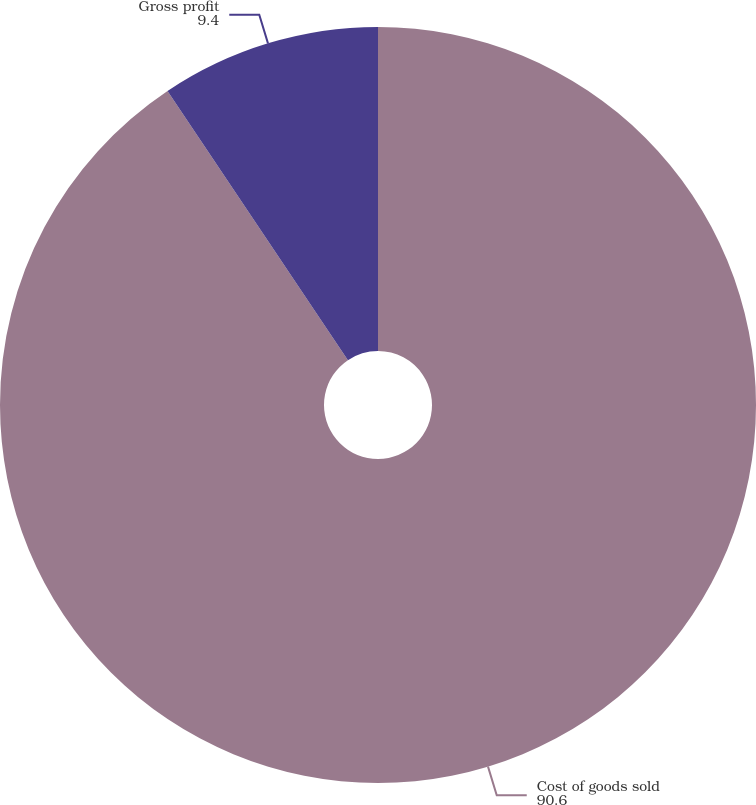Convert chart. <chart><loc_0><loc_0><loc_500><loc_500><pie_chart><fcel>Cost of goods sold<fcel>Gross profit<nl><fcel>90.6%<fcel>9.4%<nl></chart> 